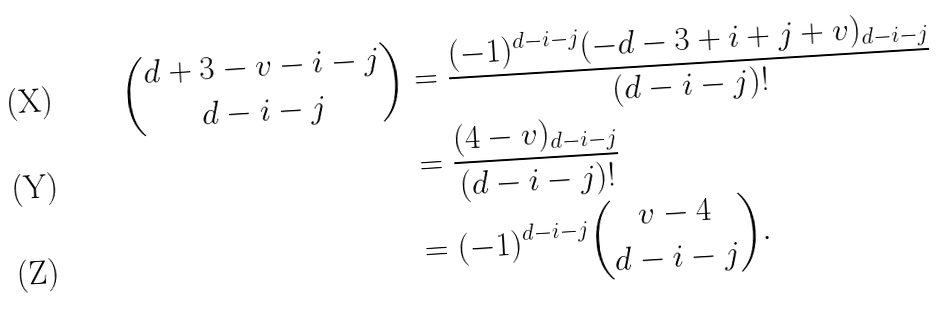Convert formula to latex. <formula><loc_0><loc_0><loc_500><loc_500>\binom { d + 3 - v - i - j } { d - i - j } & = \frac { ( - 1 ) ^ { d - i - j } ( - d - 3 + i + j + v ) _ { d - i - j } } { ( d - i - j ) ! } \\ & = \frac { ( 4 - v ) _ { d - i - j } } { ( d - i - j ) ! } \\ & = ( - 1 ) ^ { d - i - j } \binom { v - 4 } { d - i - j } .</formula> 